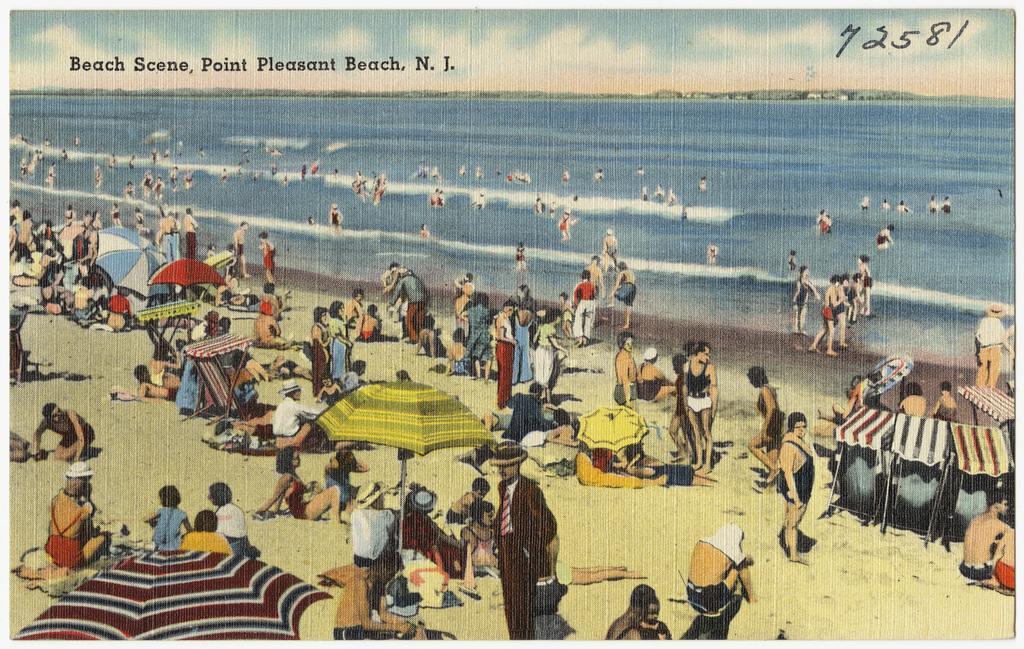Please provide a concise description of this image. This is a poster and here we can see people, umbrellas, a tent, stands and some other objects and there is water and sand. At the top, there is some text. 